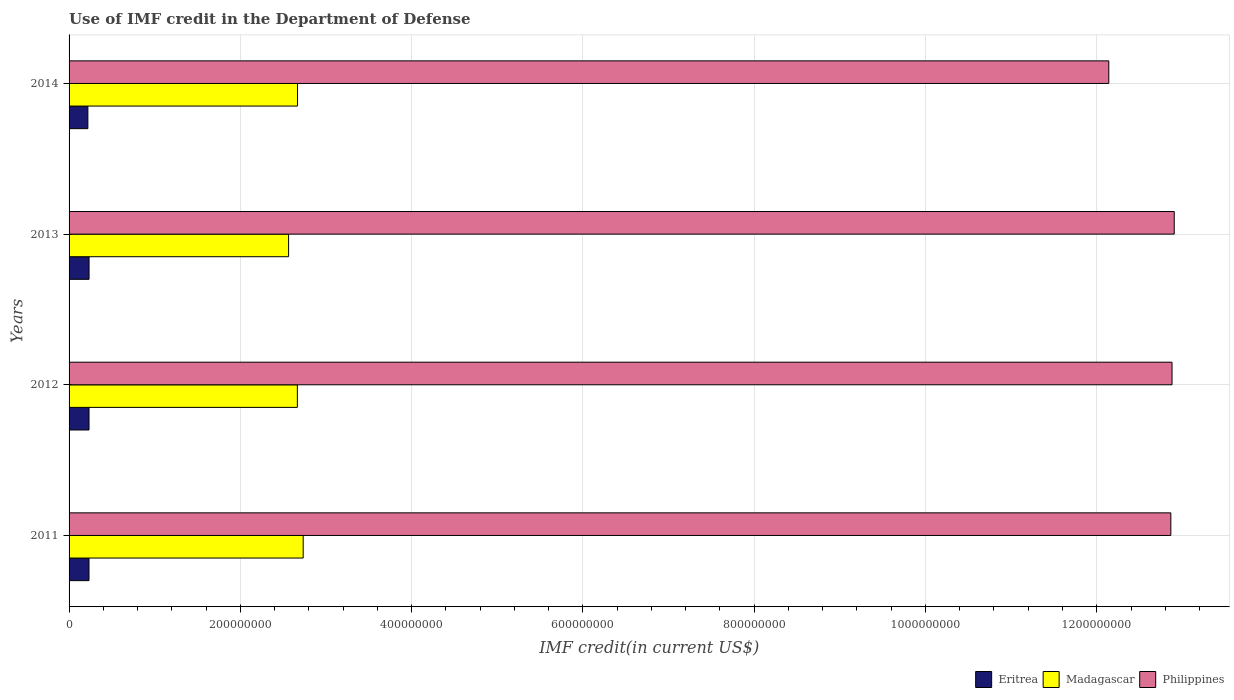Are the number of bars on each tick of the Y-axis equal?
Your response must be concise. Yes. How many bars are there on the 2nd tick from the top?
Offer a very short reply. 3. How many bars are there on the 2nd tick from the bottom?
Your answer should be compact. 3. What is the label of the 3rd group of bars from the top?
Keep it short and to the point. 2012. In how many cases, is the number of bars for a given year not equal to the number of legend labels?
Keep it short and to the point. 0. What is the IMF credit in the Department of Defense in Eritrea in 2011?
Give a very brief answer. 2.33e+07. Across all years, what is the maximum IMF credit in the Department of Defense in Eritrea?
Your response must be concise. 2.33e+07. Across all years, what is the minimum IMF credit in the Department of Defense in Philippines?
Your answer should be compact. 1.21e+09. What is the total IMF credit in the Department of Defense in Philippines in the graph?
Make the answer very short. 5.08e+09. What is the difference between the IMF credit in the Department of Defense in Madagascar in 2012 and that in 2014?
Provide a short and direct response. -2.08e+05. What is the difference between the IMF credit in the Department of Defense in Eritrea in 2011 and the IMF credit in the Department of Defense in Madagascar in 2012?
Your answer should be compact. -2.43e+08. What is the average IMF credit in the Department of Defense in Eritrea per year?
Your answer should be very brief. 2.30e+07. In the year 2014, what is the difference between the IMF credit in the Department of Defense in Eritrea and IMF credit in the Department of Defense in Philippines?
Give a very brief answer. -1.19e+09. What is the ratio of the IMF credit in the Department of Defense in Philippines in 2013 to that in 2014?
Your answer should be compact. 1.06. Is the IMF credit in the Department of Defense in Madagascar in 2011 less than that in 2013?
Offer a very short reply. No. Is the difference between the IMF credit in the Department of Defense in Eritrea in 2012 and 2013 greater than the difference between the IMF credit in the Department of Defense in Philippines in 2012 and 2013?
Make the answer very short. Yes. What is the difference between the highest and the second highest IMF credit in the Department of Defense in Philippines?
Give a very brief answer. 2.58e+06. What is the difference between the highest and the lowest IMF credit in the Department of Defense in Madagascar?
Keep it short and to the point. 1.70e+07. In how many years, is the IMF credit in the Department of Defense in Eritrea greater than the average IMF credit in the Department of Defense in Eritrea taken over all years?
Offer a very short reply. 3. What does the 1st bar from the top in 2011 represents?
Give a very brief answer. Philippines. What does the 1st bar from the bottom in 2012 represents?
Provide a succinct answer. Eritrea. How many bars are there?
Offer a terse response. 12. How many years are there in the graph?
Keep it short and to the point. 4. What is the difference between two consecutive major ticks on the X-axis?
Keep it short and to the point. 2.00e+08. Are the values on the major ticks of X-axis written in scientific E-notation?
Give a very brief answer. No. Does the graph contain any zero values?
Keep it short and to the point. No. Does the graph contain grids?
Make the answer very short. Yes. How many legend labels are there?
Provide a short and direct response. 3. How are the legend labels stacked?
Provide a succinct answer. Horizontal. What is the title of the graph?
Give a very brief answer. Use of IMF credit in the Department of Defense. Does "North America" appear as one of the legend labels in the graph?
Offer a very short reply. No. What is the label or title of the X-axis?
Provide a succinct answer. IMF credit(in current US$). What is the label or title of the Y-axis?
Make the answer very short. Years. What is the IMF credit(in current US$) of Eritrea in 2011?
Give a very brief answer. 2.33e+07. What is the IMF credit(in current US$) of Madagascar in 2011?
Keep it short and to the point. 2.73e+08. What is the IMF credit(in current US$) in Philippines in 2011?
Provide a succinct answer. 1.29e+09. What is the IMF credit(in current US$) of Eritrea in 2012?
Offer a very short reply. 2.33e+07. What is the IMF credit(in current US$) in Madagascar in 2012?
Provide a succinct answer. 2.67e+08. What is the IMF credit(in current US$) in Philippines in 2012?
Your response must be concise. 1.29e+09. What is the IMF credit(in current US$) in Eritrea in 2013?
Ensure brevity in your answer.  2.33e+07. What is the IMF credit(in current US$) of Madagascar in 2013?
Your response must be concise. 2.56e+08. What is the IMF credit(in current US$) of Philippines in 2013?
Keep it short and to the point. 1.29e+09. What is the IMF credit(in current US$) in Eritrea in 2014?
Offer a very short reply. 2.20e+07. What is the IMF credit(in current US$) in Madagascar in 2014?
Ensure brevity in your answer.  2.67e+08. What is the IMF credit(in current US$) in Philippines in 2014?
Ensure brevity in your answer.  1.21e+09. Across all years, what is the maximum IMF credit(in current US$) in Eritrea?
Provide a short and direct response. 2.33e+07. Across all years, what is the maximum IMF credit(in current US$) of Madagascar?
Offer a very short reply. 2.73e+08. Across all years, what is the maximum IMF credit(in current US$) in Philippines?
Give a very brief answer. 1.29e+09. Across all years, what is the minimum IMF credit(in current US$) in Eritrea?
Your answer should be compact. 2.20e+07. Across all years, what is the minimum IMF credit(in current US$) of Madagascar?
Your response must be concise. 2.56e+08. Across all years, what is the minimum IMF credit(in current US$) of Philippines?
Your response must be concise. 1.21e+09. What is the total IMF credit(in current US$) in Eritrea in the graph?
Your answer should be very brief. 9.19e+07. What is the total IMF credit(in current US$) of Madagascar in the graph?
Provide a short and direct response. 1.06e+09. What is the total IMF credit(in current US$) of Philippines in the graph?
Offer a very short reply. 5.08e+09. What is the difference between the IMF credit(in current US$) of Eritrea in 2011 and that in 2012?
Offer a terse response. -2.50e+04. What is the difference between the IMF credit(in current US$) in Madagascar in 2011 and that in 2012?
Offer a very short reply. 6.82e+06. What is the difference between the IMF credit(in current US$) in Philippines in 2011 and that in 2012?
Offer a terse response. -1.38e+06. What is the difference between the IMF credit(in current US$) in Eritrea in 2011 and that in 2013?
Offer a terse response. -7.20e+04. What is the difference between the IMF credit(in current US$) of Madagascar in 2011 and that in 2013?
Provide a short and direct response. 1.70e+07. What is the difference between the IMF credit(in current US$) of Philippines in 2011 and that in 2013?
Your answer should be compact. -3.96e+06. What is the difference between the IMF credit(in current US$) of Eritrea in 2011 and that in 2014?
Your answer should be compact. 1.31e+06. What is the difference between the IMF credit(in current US$) in Madagascar in 2011 and that in 2014?
Your response must be concise. 6.61e+06. What is the difference between the IMF credit(in current US$) of Philippines in 2011 and that in 2014?
Give a very brief answer. 7.24e+07. What is the difference between the IMF credit(in current US$) of Eritrea in 2012 and that in 2013?
Your response must be concise. -4.70e+04. What is the difference between the IMF credit(in current US$) in Madagascar in 2012 and that in 2013?
Your response must be concise. 1.02e+07. What is the difference between the IMF credit(in current US$) of Philippines in 2012 and that in 2013?
Keep it short and to the point. -2.58e+06. What is the difference between the IMF credit(in current US$) of Eritrea in 2012 and that in 2014?
Ensure brevity in your answer.  1.34e+06. What is the difference between the IMF credit(in current US$) of Madagascar in 2012 and that in 2014?
Your answer should be compact. -2.08e+05. What is the difference between the IMF credit(in current US$) of Philippines in 2012 and that in 2014?
Provide a succinct answer. 7.38e+07. What is the difference between the IMF credit(in current US$) in Eritrea in 2013 and that in 2014?
Give a very brief answer. 1.38e+06. What is the difference between the IMF credit(in current US$) of Madagascar in 2013 and that in 2014?
Your answer should be very brief. -1.04e+07. What is the difference between the IMF credit(in current US$) of Philippines in 2013 and that in 2014?
Your response must be concise. 7.64e+07. What is the difference between the IMF credit(in current US$) of Eritrea in 2011 and the IMF credit(in current US$) of Madagascar in 2012?
Ensure brevity in your answer.  -2.43e+08. What is the difference between the IMF credit(in current US$) in Eritrea in 2011 and the IMF credit(in current US$) in Philippines in 2012?
Keep it short and to the point. -1.26e+09. What is the difference between the IMF credit(in current US$) of Madagascar in 2011 and the IMF credit(in current US$) of Philippines in 2012?
Offer a very short reply. -1.01e+09. What is the difference between the IMF credit(in current US$) in Eritrea in 2011 and the IMF credit(in current US$) in Madagascar in 2013?
Provide a short and direct response. -2.33e+08. What is the difference between the IMF credit(in current US$) of Eritrea in 2011 and the IMF credit(in current US$) of Philippines in 2013?
Offer a very short reply. -1.27e+09. What is the difference between the IMF credit(in current US$) in Madagascar in 2011 and the IMF credit(in current US$) in Philippines in 2013?
Provide a succinct answer. -1.02e+09. What is the difference between the IMF credit(in current US$) in Eritrea in 2011 and the IMF credit(in current US$) in Madagascar in 2014?
Provide a short and direct response. -2.43e+08. What is the difference between the IMF credit(in current US$) of Eritrea in 2011 and the IMF credit(in current US$) of Philippines in 2014?
Keep it short and to the point. -1.19e+09. What is the difference between the IMF credit(in current US$) in Madagascar in 2011 and the IMF credit(in current US$) in Philippines in 2014?
Offer a very short reply. -9.41e+08. What is the difference between the IMF credit(in current US$) of Eritrea in 2012 and the IMF credit(in current US$) of Madagascar in 2013?
Your response must be concise. -2.33e+08. What is the difference between the IMF credit(in current US$) of Eritrea in 2012 and the IMF credit(in current US$) of Philippines in 2013?
Provide a short and direct response. -1.27e+09. What is the difference between the IMF credit(in current US$) of Madagascar in 2012 and the IMF credit(in current US$) of Philippines in 2013?
Ensure brevity in your answer.  -1.02e+09. What is the difference between the IMF credit(in current US$) in Eritrea in 2012 and the IMF credit(in current US$) in Madagascar in 2014?
Provide a short and direct response. -2.43e+08. What is the difference between the IMF credit(in current US$) of Eritrea in 2012 and the IMF credit(in current US$) of Philippines in 2014?
Keep it short and to the point. -1.19e+09. What is the difference between the IMF credit(in current US$) of Madagascar in 2012 and the IMF credit(in current US$) of Philippines in 2014?
Keep it short and to the point. -9.47e+08. What is the difference between the IMF credit(in current US$) in Eritrea in 2013 and the IMF credit(in current US$) in Madagascar in 2014?
Your answer should be compact. -2.43e+08. What is the difference between the IMF credit(in current US$) of Eritrea in 2013 and the IMF credit(in current US$) of Philippines in 2014?
Ensure brevity in your answer.  -1.19e+09. What is the difference between the IMF credit(in current US$) of Madagascar in 2013 and the IMF credit(in current US$) of Philippines in 2014?
Offer a terse response. -9.58e+08. What is the average IMF credit(in current US$) in Eritrea per year?
Your answer should be compact. 2.30e+07. What is the average IMF credit(in current US$) of Madagascar per year?
Make the answer very short. 2.66e+08. What is the average IMF credit(in current US$) of Philippines per year?
Provide a short and direct response. 1.27e+09. In the year 2011, what is the difference between the IMF credit(in current US$) of Eritrea and IMF credit(in current US$) of Madagascar?
Your answer should be compact. -2.50e+08. In the year 2011, what is the difference between the IMF credit(in current US$) in Eritrea and IMF credit(in current US$) in Philippines?
Make the answer very short. -1.26e+09. In the year 2011, what is the difference between the IMF credit(in current US$) in Madagascar and IMF credit(in current US$) in Philippines?
Offer a very short reply. -1.01e+09. In the year 2012, what is the difference between the IMF credit(in current US$) in Eritrea and IMF credit(in current US$) in Madagascar?
Your answer should be very brief. -2.43e+08. In the year 2012, what is the difference between the IMF credit(in current US$) of Eritrea and IMF credit(in current US$) of Philippines?
Make the answer very short. -1.26e+09. In the year 2012, what is the difference between the IMF credit(in current US$) of Madagascar and IMF credit(in current US$) of Philippines?
Provide a short and direct response. -1.02e+09. In the year 2013, what is the difference between the IMF credit(in current US$) of Eritrea and IMF credit(in current US$) of Madagascar?
Provide a succinct answer. -2.33e+08. In the year 2013, what is the difference between the IMF credit(in current US$) of Eritrea and IMF credit(in current US$) of Philippines?
Provide a short and direct response. -1.27e+09. In the year 2013, what is the difference between the IMF credit(in current US$) of Madagascar and IMF credit(in current US$) of Philippines?
Offer a terse response. -1.03e+09. In the year 2014, what is the difference between the IMF credit(in current US$) in Eritrea and IMF credit(in current US$) in Madagascar?
Your response must be concise. -2.45e+08. In the year 2014, what is the difference between the IMF credit(in current US$) in Eritrea and IMF credit(in current US$) in Philippines?
Give a very brief answer. -1.19e+09. In the year 2014, what is the difference between the IMF credit(in current US$) in Madagascar and IMF credit(in current US$) in Philippines?
Make the answer very short. -9.47e+08. What is the ratio of the IMF credit(in current US$) of Madagascar in 2011 to that in 2012?
Provide a succinct answer. 1.03. What is the ratio of the IMF credit(in current US$) in Madagascar in 2011 to that in 2013?
Give a very brief answer. 1.07. What is the ratio of the IMF credit(in current US$) of Eritrea in 2011 to that in 2014?
Your response must be concise. 1.06. What is the ratio of the IMF credit(in current US$) in Madagascar in 2011 to that in 2014?
Your response must be concise. 1.02. What is the ratio of the IMF credit(in current US$) of Philippines in 2011 to that in 2014?
Provide a succinct answer. 1.06. What is the ratio of the IMF credit(in current US$) in Eritrea in 2012 to that in 2013?
Your answer should be very brief. 1. What is the ratio of the IMF credit(in current US$) of Madagascar in 2012 to that in 2013?
Your answer should be compact. 1.04. What is the ratio of the IMF credit(in current US$) of Eritrea in 2012 to that in 2014?
Provide a succinct answer. 1.06. What is the ratio of the IMF credit(in current US$) in Madagascar in 2012 to that in 2014?
Keep it short and to the point. 1. What is the ratio of the IMF credit(in current US$) in Philippines in 2012 to that in 2014?
Ensure brevity in your answer.  1.06. What is the ratio of the IMF credit(in current US$) in Eritrea in 2013 to that in 2014?
Offer a terse response. 1.06. What is the ratio of the IMF credit(in current US$) of Madagascar in 2013 to that in 2014?
Make the answer very short. 0.96. What is the ratio of the IMF credit(in current US$) of Philippines in 2013 to that in 2014?
Provide a succinct answer. 1.06. What is the difference between the highest and the second highest IMF credit(in current US$) in Eritrea?
Ensure brevity in your answer.  4.70e+04. What is the difference between the highest and the second highest IMF credit(in current US$) of Madagascar?
Your response must be concise. 6.61e+06. What is the difference between the highest and the second highest IMF credit(in current US$) in Philippines?
Keep it short and to the point. 2.58e+06. What is the difference between the highest and the lowest IMF credit(in current US$) in Eritrea?
Your response must be concise. 1.38e+06. What is the difference between the highest and the lowest IMF credit(in current US$) in Madagascar?
Make the answer very short. 1.70e+07. What is the difference between the highest and the lowest IMF credit(in current US$) of Philippines?
Your response must be concise. 7.64e+07. 